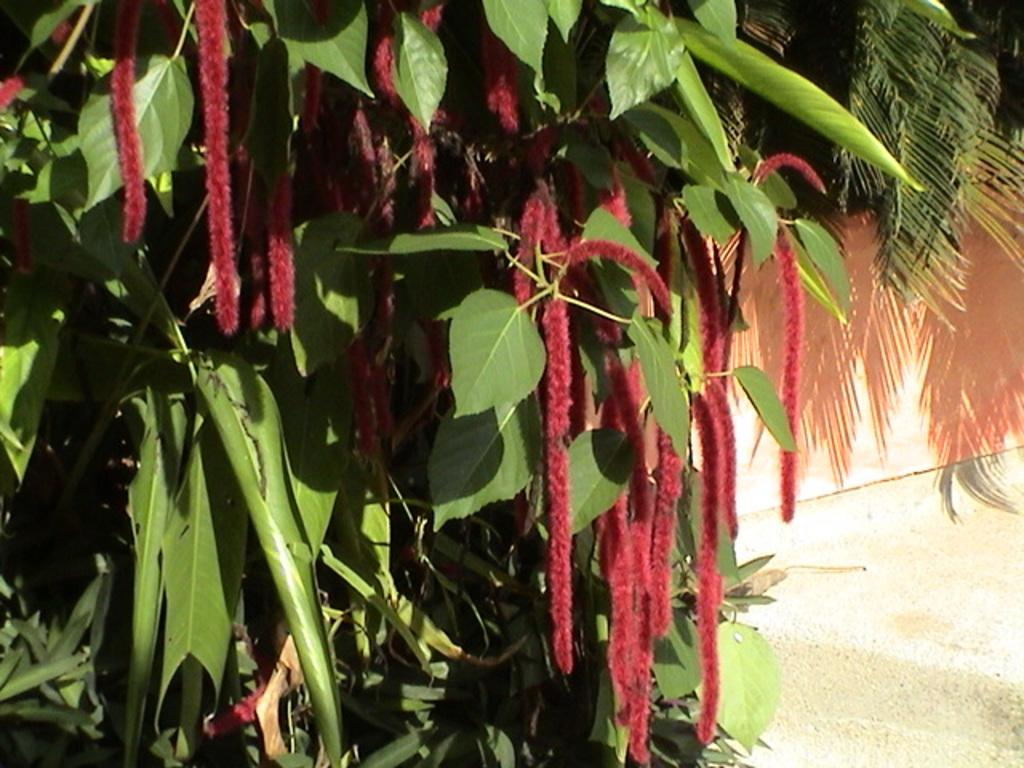What type of vegetation can be seen in the image? There are trees in the image. What can be used for walking or traveling in the image? There is a path in the image. What architectural feature is visible in the background of the image? There is a wall visible in the background of the image. What grade is the plantation in the image? There is no plantation present in the image, so it is not possible to determine its grade. How can the person in the image be helped to find their way? There is no person present in the image, so it is not possible to help them find their way. 